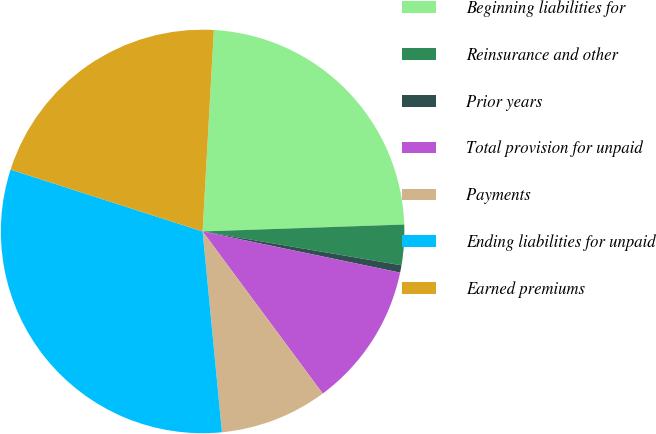<chart> <loc_0><loc_0><loc_500><loc_500><pie_chart><fcel>Beginning liabilities for<fcel>Reinsurance and other<fcel>Prior years<fcel>Total provision for unpaid<fcel>Payments<fcel>Ending liabilities for unpaid<fcel>Earned premiums<nl><fcel>23.57%<fcel>3.23%<fcel>0.59%<fcel>11.58%<fcel>8.62%<fcel>31.49%<fcel>20.93%<nl></chart> 